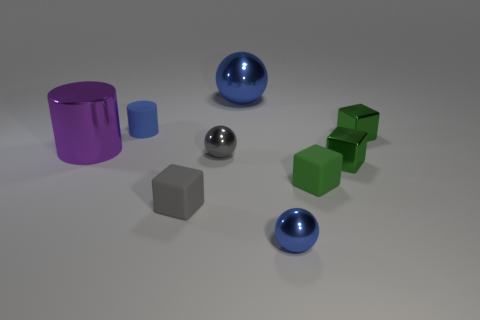How many green cubes must be subtracted to get 1 green cubes? 2 Subtract all green blocks. How many blocks are left? 1 Add 1 small yellow matte cubes. How many objects exist? 10 Subtract all gray blocks. How many blue spheres are left? 2 Subtract all spheres. How many objects are left? 6 Subtract 3 cubes. How many cubes are left? 1 Subtract all purple cylinders. How many cylinders are left? 1 Subtract 0 brown cubes. How many objects are left? 9 Subtract all brown cylinders. Subtract all yellow cubes. How many cylinders are left? 2 Subtract all green spheres. Subtract all purple metallic things. How many objects are left? 8 